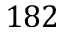Convert formula to latex. <formula><loc_0><loc_0><loc_500><loc_500>1 8 2</formula> 